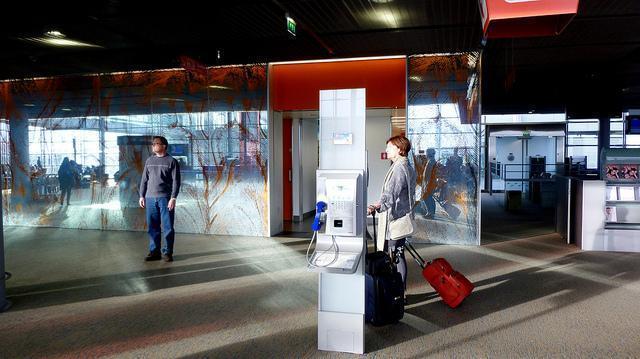How many people are there?
Give a very brief answer. 2. 